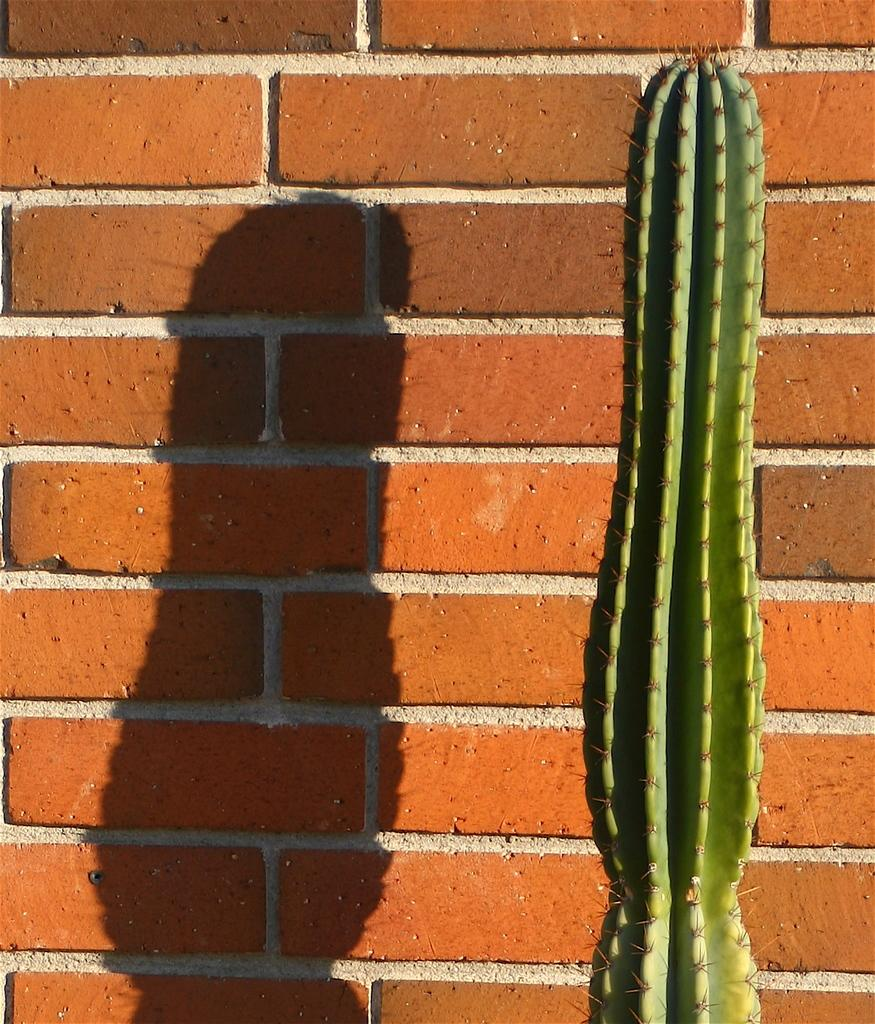What type of plant is in the image? There is a cactus plant in the image. Where is the cactus plant located in the image? The cactus plant is on the right side of the image. What can be seen in the background of the image? There is a brick wall in the background of the image. What is the result of the cactus plant's position in relation to the wall? The shadow of the plant is visible on the wall. Where can you find a copy of the toothbrush in the image? There is no toothbrush present in the image, so it cannot be copied or found. 